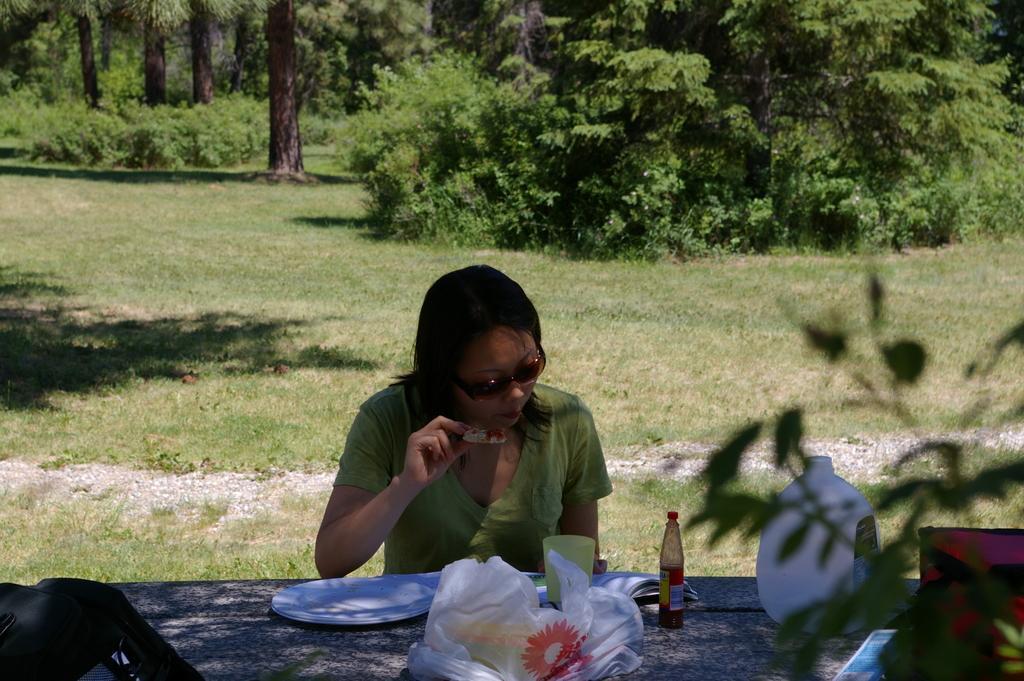Please provide a concise description of this image. In this image we can see a woman wearing the glasses and holding the food item. We can also see a sauce bottle, book, white color object, plate and also a cover on the table. In the background we can see the grass and also trees. 